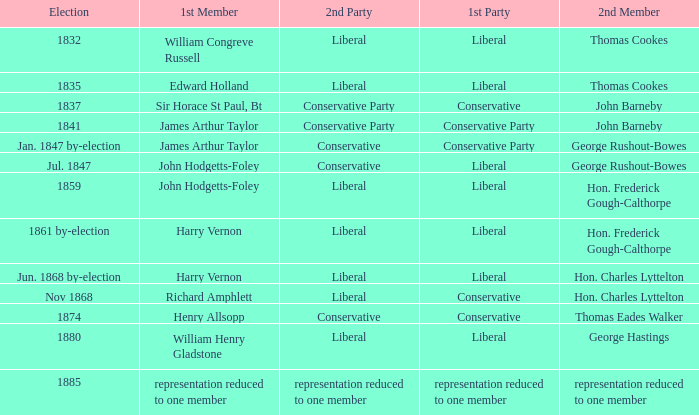What was the 2nd Party that had the 2nd Member John Barneby, when the 1st Party was Conservative? Conservative Party. 